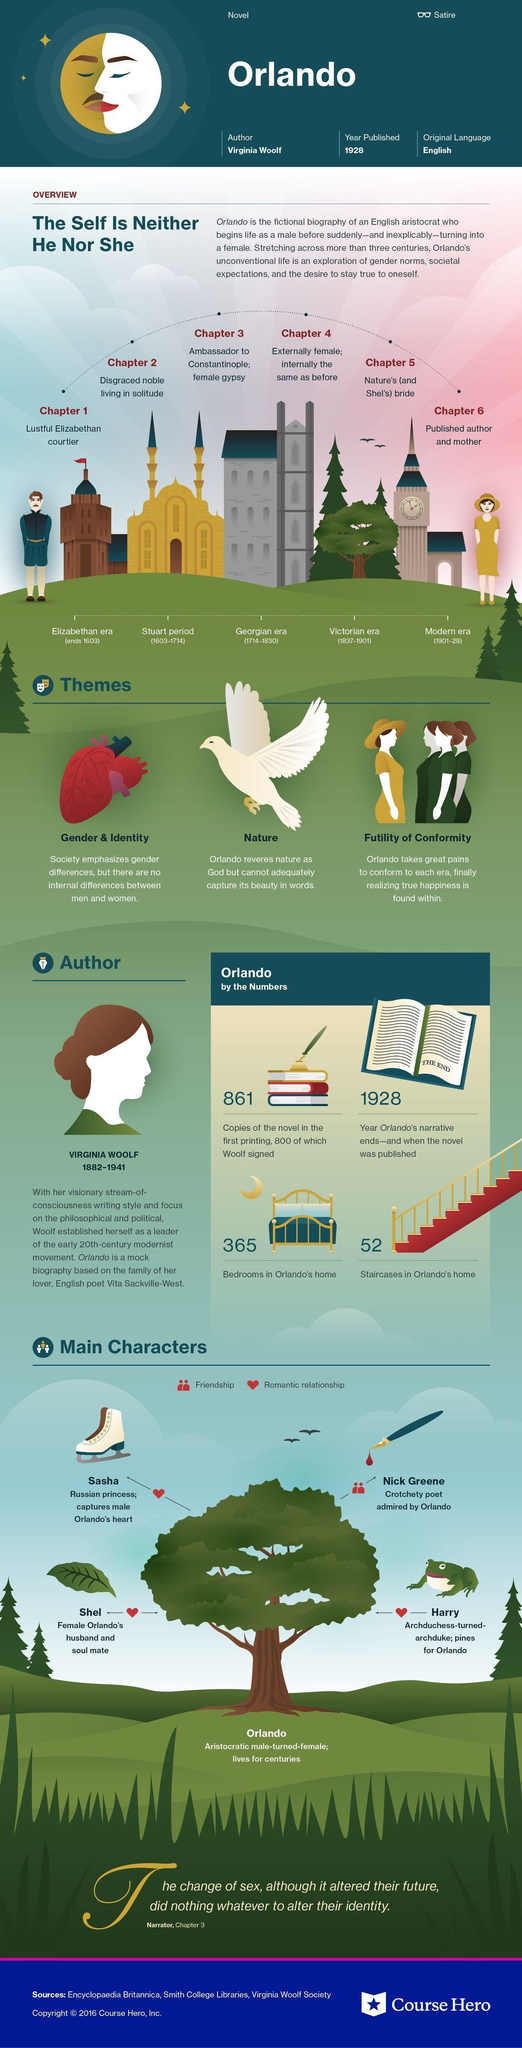What is second chapter of Orlando?
Answer the question with a short phrase. Disgraced noble living in solitude What are the themes of Orlando? Gender & identity, nature, futility of conformity In which color the main heading is written - white, blue or black? white Which are the main characters who had romantic relationship with Orlando? Sasha, Harry, Shel in which year narration of "modern era" ended in the novel Orlando? 1928 When was Virginia Woolf  died? 1941 What is 5th chapter of Orlando about? Nature's (and Shel's) bride what was the relationship of Orlando and Nick green? friendship 